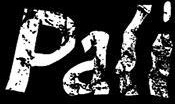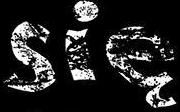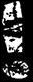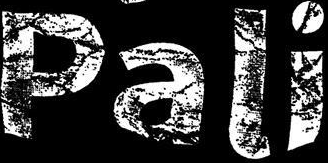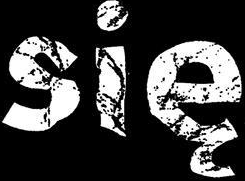What words can you see in these images in sequence, separated by a semicolon? Pali; się; !; Pali; się 